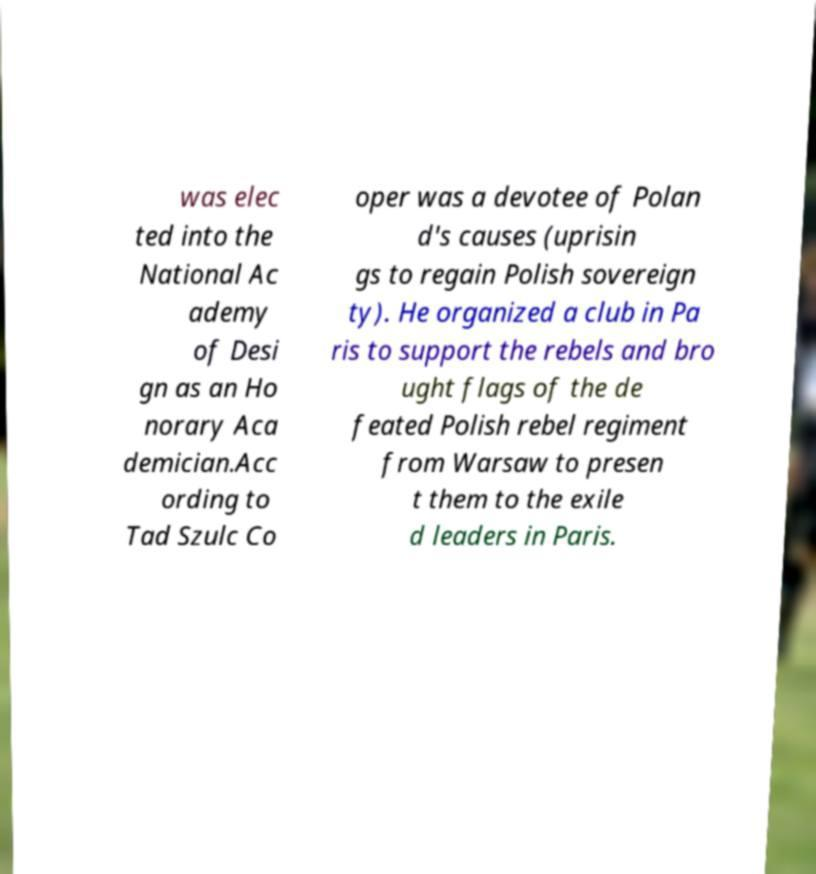Could you assist in decoding the text presented in this image and type it out clearly? was elec ted into the National Ac ademy of Desi gn as an Ho norary Aca demician.Acc ording to Tad Szulc Co oper was a devotee of Polan d's causes (uprisin gs to regain Polish sovereign ty). He organized a club in Pa ris to support the rebels and bro ught flags of the de feated Polish rebel regiment from Warsaw to presen t them to the exile d leaders in Paris. 